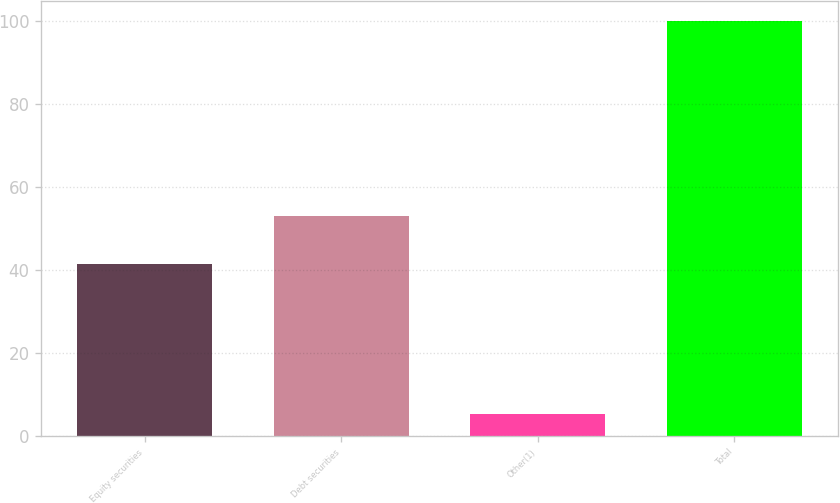Convert chart to OTSL. <chart><loc_0><loc_0><loc_500><loc_500><bar_chart><fcel>Equity securities<fcel>Debt securities<fcel>Other(1)<fcel>Total<nl><fcel>41.5<fcel>53.1<fcel>5.4<fcel>100<nl></chart> 